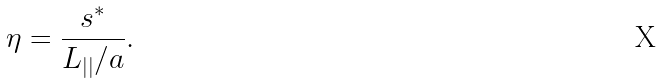Convert formula to latex. <formula><loc_0><loc_0><loc_500><loc_500>\eta = \frac { s ^ { * } } { L _ { | | } / a } .</formula> 